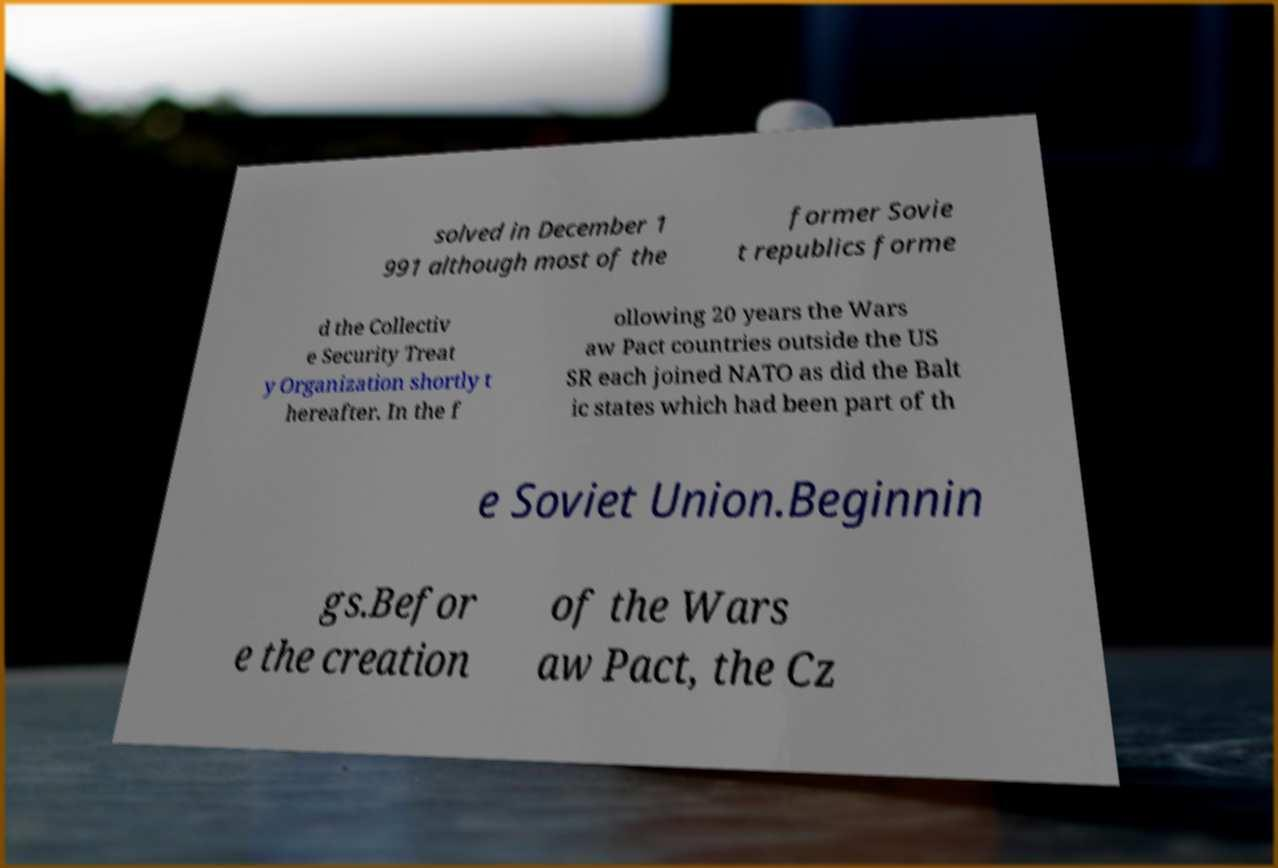Can you accurately transcribe the text from the provided image for me? solved in December 1 991 although most of the former Sovie t republics forme d the Collectiv e Security Treat y Organization shortly t hereafter. In the f ollowing 20 years the Wars aw Pact countries outside the US SR each joined NATO as did the Balt ic states which had been part of th e Soviet Union.Beginnin gs.Befor e the creation of the Wars aw Pact, the Cz 